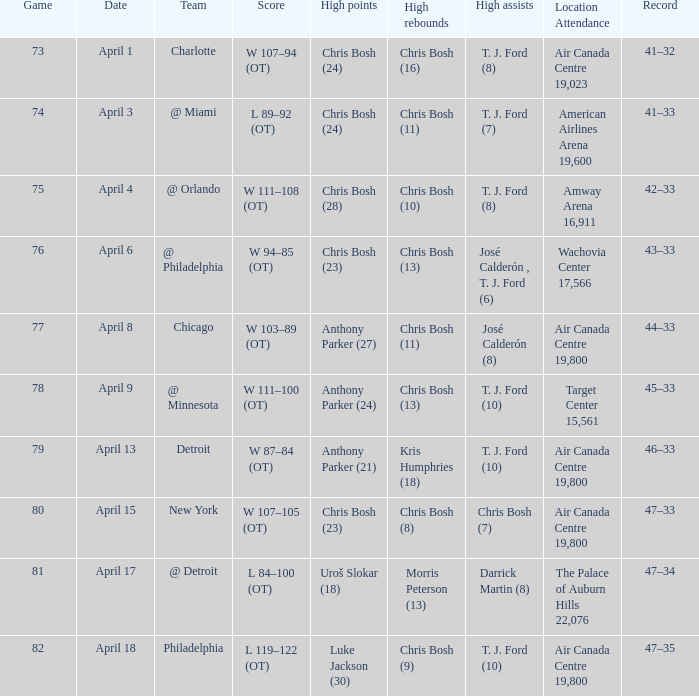What was the outcome of game 82? L 119–122 (OT). 